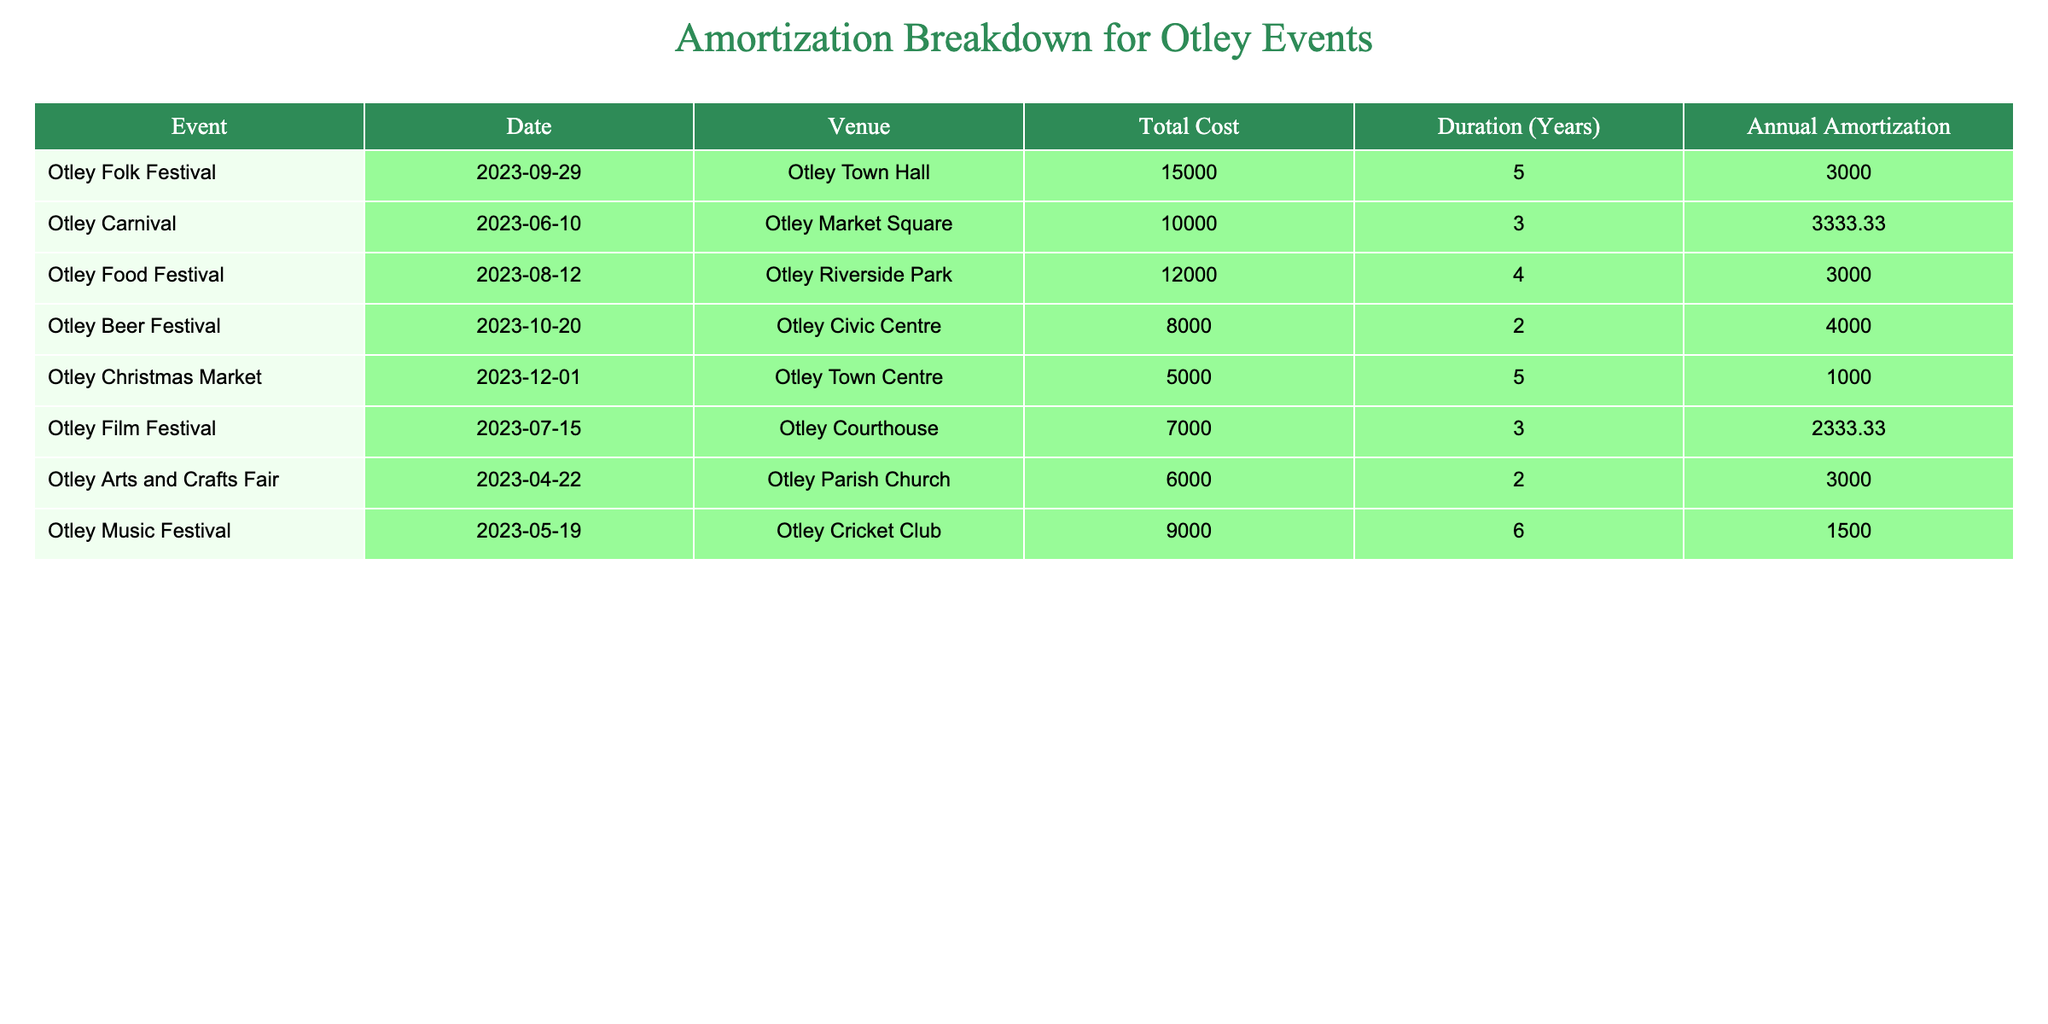What is the total cost for the Otley Folk Festival? The table shows the "Total Cost" column for the Otley Folk Festival where the event's total cost is listed as 15000.
Answer: 15000 Which event has the lowest annual amortization? Looking at the "Annual Amortization" column, the Otley Christmas Market has the lowest value listed as 1000.
Answer: 1000 What is the total cost for all events that last for 5 years? The events with a duration of 5 years are the Otley Folk Festival and the Otley Christmas Market. Their total costs are 15000 (Folk Festival) and 5000 (Christmas Market), so the total is 15000 + 5000 = 20000.
Answer: 20000 How many events are held at Otley Town Hall? By checking the "Venue" column, the Otley Folk Festival and the Otley Christmas Market are both held at the Otley Town Hall. Hence, there are 2 events at this venue.
Answer: 2 Is the Otley Beer Festival more expensive than the Otley Food Festival? Comparing the "Total Cost" of both events, the Otley Beer Festival costs 8000 while the Otley Food Festival costs 12000. Since 8000 is less than 12000, the statement is false.
Answer: No What is the average annual amortization for all festivals held in Otley? Calculating the average involves summing all values in the "Annual Amortization" column: 3000 + 3333.33 + 3000 + 4000 + 1000 + 2333.33 + 3000 + 1500 = 22166.66. Dividing by the 8 events gives an average of 22166.66 / 8 = 2770.83.
Answer: 2770.83 Which event has the highest total cost and what is that cost? Reviewing the "Total Cost" column, the Otley Folk Festival has the highest total cost listed at 15000.
Answer: 15000 If we combined the total costs for the Otley Music Festival and the Otley Beer Festival, what would that be? The total cost for the Otley Music Festival is 9000 and for the Otley Beer Festival it is 8000. Adding these together gives 9000 + 8000 = 17000.
Answer: 17000 Which event has a duration of 2 years? By examining the "Duration" column, the Otley Beer Festival and the Otley Arts and Crafts Fair both have a duration of 2 years.
Answer: Otley Beer Festival and Otley Arts and Crafts Fair 